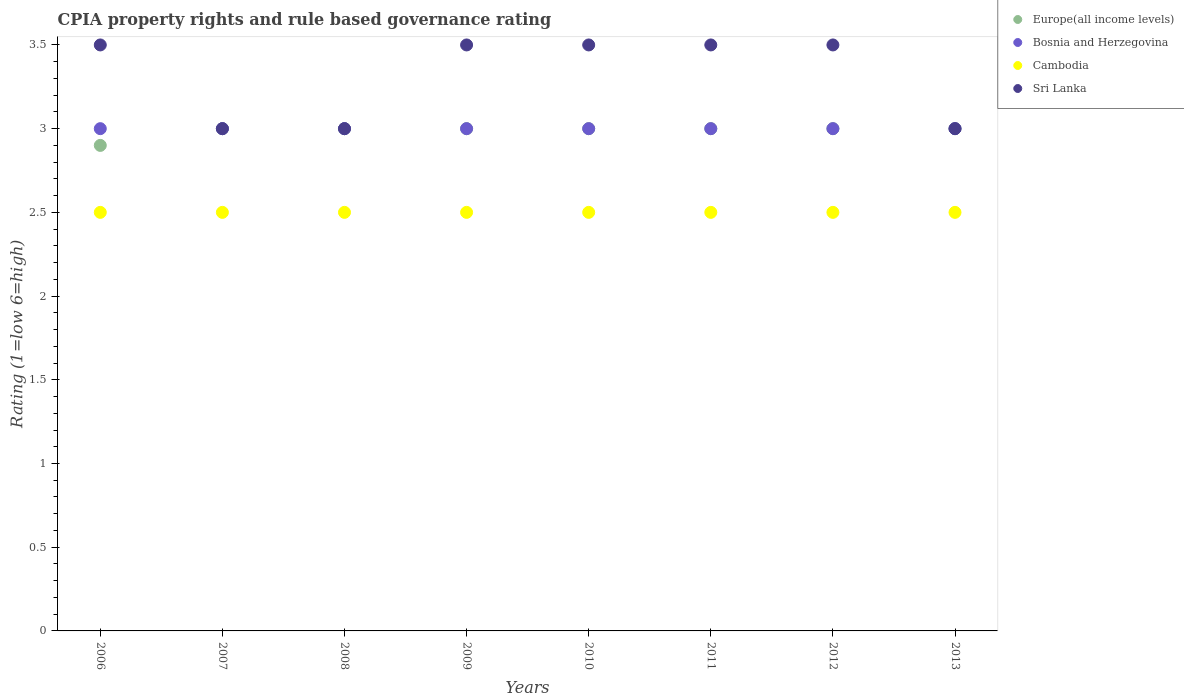How many different coloured dotlines are there?
Offer a terse response. 4. What is the CPIA rating in Cambodia in 2013?
Provide a succinct answer. 2.5. In which year was the CPIA rating in Bosnia and Herzegovina maximum?
Keep it short and to the point. 2006. In which year was the CPIA rating in Sri Lanka minimum?
Keep it short and to the point. 2007. What is the total CPIA rating in Europe(all income levels) in the graph?
Your answer should be very brief. 23.9. What is the difference between the CPIA rating in Cambodia in 2011 and that in 2012?
Provide a short and direct response. 0. What is the difference between the CPIA rating in Cambodia in 2010 and the CPIA rating in Europe(all income levels) in 2007?
Your answer should be compact. -0.5. What is the average CPIA rating in Europe(all income levels) per year?
Your answer should be compact. 2.99. In the year 2006, what is the difference between the CPIA rating in Europe(all income levels) and CPIA rating in Sri Lanka?
Your response must be concise. -0.6. In how many years, is the CPIA rating in Europe(all income levels) greater than 2.2?
Your response must be concise. 8. What is the ratio of the CPIA rating in Sri Lanka in 2007 to that in 2012?
Make the answer very short. 0.86. Is the CPIA rating in Cambodia in 2008 less than that in 2012?
Offer a terse response. No. Is the difference between the CPIA rating in Europe(all income levels) in 2007 and 2012 greater than the difference between the CPIA rating in Sri Lanka in 2007 and 2012?
Keep it short and to the point. Yes. In how many years, is the CPIA rating in Europe(all income levels) greater than the average CPIA rating in Europe(all income levels) taken over all years?
Make the answer very short. 7. Is it the case that in every year, the sum of the CPIA rating in Cambodia and CPIA rating in Bosnia and Herzegovina  is greater than the sum of CPIA rating in Sri Lanka and CPIA rating in Europe(all income levels)?
Offer a terse response. No. Is it the case that in every year, the sum of the CPIA rating in Sri Lanka and CPIA rating in Bosnia and Herzegovina  is greater than the CPIA rating in Europe(all income levels)?
Offer a terse response. Yes. Is the CPIA rating in Europe(all income levels) strictly less than the CPIA rating in Sri Lanka over the years?
Your answer should be very brief. No. How many years are there in the graph?
Your answer should be very brief. 8. What is the difference between two consecutive major ticks on the Y-axis?
Give a very brief answer. 0.5. Are the values on the major ticks of Y-axis written in scientific E-notation?
Your answer should be very brief. No. Does the graph contain any zero values?
Offer a terse response. No. Does the graph contain grids?
Provide a succinct answer. No. What is the title of the graph?
Your response must be concise. CPIA property rights and rule based governance rating. What is the Rating (1=low 6=high) of Europe(all income levels) in 2007?
Offer a very short reply. 3. What is the Rating (1=low 6=high) of Bosnia and Herzegovina in 2007?
Make the answer very short. 3. What is the Rating (1=low 6=high) in Cambodia in 2007?
Give a very brief answer. 2.5. What is the Rating (1=low 6=high) in Europe(all income levels) in 2008?
Ensure brevity in your answer.  3. What is the Rating (1=low 6=high) in Sri Lanka in 2008?
Provide a short and direct response. 3. What is the Rating (1=low 6=high) in Europe(all income levels) in 2009?
Provide a short and direct response. 3. What is the Rating (1=low 6=high) of Bosnia and Herzegovina in 2009?
Offer a terse response. 3. What is the Rating (1=low 6=high) of Cambodia in 2009?
Your answer should be very brief. 2.5. What is the Rating (1=low 6=high) in Sri Lanka in 2009?
Offer a terse response. 3.5. What is the Rating (1=low 6=high) in Sri Lanka in 2010?
Keep it short and to the point. 3.5. What is the Rating (1=low 6=high) of Cambodia in 2011?
Your answer should be compact. 2.5. What is the Rating (1=low 6=high) in Sri Lanka in 2011?
Make the answer very short. 3.5. What is the Rating (1=low 6=high) of Europe(all income levels) in 2012?
Provide a short and direct response. 3. What is the Rating (1=low 6=high) in Sri Lanka in 2012?
Provide a succinct answer. 3.5. What is the Rating (1=low 6=high) of Bosnia and Herzegovina in 2013?
Offer a terse response. 3. What is the Rating (1=low 6=high) in Cambodia in 2013?
Offer a terse response. 2.5. What is the Rating (1=low 6=high) of Sri Lanka in 2013?
Provide a succinct answer. 3. Across all years, what is the minimum Rating (1=low 6=high) of Bosnia and Herzegovina?
Give a very brief answer. 3. Across all years, what is the minimum Rating (1=low 6=high) in Cambodia?
Your answer should be compact. 2.5. What is the total Rating (1=low 6=high) in Europe(all income levels) in the graph?
Your response must be concise. 23.9. What is the total Rating (1=low 6=high) of Bosnia and Herzegovina in the graph?
Offer a very short reply. 24. What is the total Rating (1=low 6=high) in Sri Lanka in the graph?
Provide a succinct answer. 26.5. What is the difference between the Rating (1=low 6=high) of Europe(all income levels) in 2006 and that in 2007?
Your answer should be compact. -0.1. What is the difference between the Rating (1=low 6=high) of Cambodia in 2006 and that in 2007?
Keep it short and to the point. 0. What is the difference between the Rating (1=low 6=high) in Europe(all income levels) in 2006 and that in 2008?
Make the answer very short. -0.1. What is the difference between the Rating (1=low 6=high) of Bosnia and Herzegovina in 2006 and that in 2009?
Your answer should be compact. 0. What is the difference between the Rating (1=low 6=high) in Cambodia in 2006 and that in 2009?
Offer a terse response. 0. What is the difference between the Rating (1=low 6=high) of Europe(all income levels) in 2006 and that in 2010?
Provide a succinct answer. -0.1. What is the difference between the Rating (1=low 6=high) in Bosnia and Herzegovina in 2006 and that in 2010?
Keep it short and to the point. 0. What is the difference between the Rating (1=low 6=high) in Cambodia in 2006 and that in 2010?
Provide a short and direct response. 0. What is the difference between the Rating (1=low 6=high) in Sri Lanka in 2006 and that in 2010?
Provide a short and direct response. 0. What is the difference between the Rating (1=low 6=high) of Bosnia and Herzegovina in 2006 and that in 2011?
Your answer should be very brief. 0. What is the difference between the Rating (1=low 6=high) in Sri Lanka in 2006 and that in 2011?
Provide a short and direct response. 0. What is the difference between the Rating (1=low 6=high) in Bosnia and Herzegovina in 2006 and that in 2012?
Keep it short and to the point. 0. What is the difference between the Rating (1=low 6=high) of Cambodia in 2006 and that in 2012?
Your answer should be very brief. 0. What is the difference between the Rating (1=low 6=high) of Sri Lanka in 2006 and that in 2012?
Provide a short and direct response. 0. What is the difference between the Rating (1=low 6=high) of Cambodia in 2006 and that in 2013?
Give a very brief answer. 0. What is the difference between the Rating (1=low 6=high) of Sri Lanka in 2006 and that in 2013?
Make the answer very short. 0.5. What is the difference between the Rating (1=low 6=high) of Europe(all income levels) in 2007 and that in 2008?
Provide a succinct answer. 0. What is the difference between the Rating (1=low 6=high) of Europe(all income levels) in 2007 and that in 2009?
Give a very brief answer. 0. What is the difference between the Rating (1=low 6=high) of Bosnia and Herzegovina in 2007 and that in 2009?
Your response must be concise. 0. What is the difference between the Rating (1=low 6=high) in Sri Lanka in 2007 and that in 2009?
Your answer should be very brief. -0.5. What is the difference between the Rating (1=low 6=high) of Europe(all income levels) in 2007 and that in 2010?
Your answer should be compact. 0. What is the difference between the Rating (1=low 6=high) of Bosnia and Herzegovina in 2007 and that in 2010?
Provide a succinct answer. 0. What is the difference between the Rating (1=low 6=high) in Cambodia in 2007 and that in 2010?
Give a very brief answer. 0. What is the difference between the Rating (1=low 6=high) of Europe(all income levels) in 2007 and that in 2011?
Ensure brevity in your answer.  0. What is the difference between the Rating (1=low 6=high) of Europe(all income levels) in 2007 and that in 2012?
Provide a short and direct response. 0. What is the difference between the Rating (1=low 6=high) in Bosnia and Herzegovina in 2007 and that in 2012?
Your answer should be very brief. 0. What is the difference between the Rating (1=low 6=high) of Bosnia and Herzegovina in 2007 and that in 2013?
Ensure brevity in your answer.  0. What is the difference between the Rating (1=low 6=high) of Sri Lanka in 2007 and that in 2013?
Offer a terse response. 0. What is the difference between the Rating (1=low 6=high) of Bosnia and Herzegovina in 2008 and that in 2009?
Keep it short and to the point. 0. What is the difference between the Rating (1=low 6=high) in Cambodia in 2008 and that in 2009?
Ensure brevity in your answer.  0. What is the difference between the Rating (1=low 6=high) in Cambodia in 2008 and that in 2010?
Make the answer very short. 0. What is the difference between the Rating (1=low 6=high) in Sri Lanka in 2008 and that in 2010?
Make the answer very short. -0.5. What is the difference between the Rating (1=low 6=high) of Europe(all income levels) in 2008 and that in 2011?
Keep it short and to the point. 0. What is the difference between the Rating (1=low 6=high) in Bosnia and Herzegovina in 2008 and that in 2011?
Your response must be concise. 0. What is the difference between the Rating (1=low 6=high) of Cambodia in 2008 and that in 2011?
Your response must be concise. 0. What is the difference between the Rating (1=low 6=high) in Sri Lanka in 2008 and that in 2011?
Make the answer very short. -0.5. What is the difference between the Rating (1=low 6=high) in Europe(all income levels) in 2008 and that in 2012?
Offer a terse response. 0. What is the difference between the Rating (1=low 6=high) in Bosnia and Herzegovina in 2008 and that in 2012?
Provide a succinct answer. 0. What is the difference between the Rating (1=low 6=high) in Cambodia in 2008 and that in 2012?
Provide a succinct answer. 0. What is the difference between the Rating (1=low 6=high) in Sri Lanka in 2008 and that in 2012?
Provide a succinct answer. -0.5. What is the difference between the Rating (1=low 6=high) in Cambodia in 2009 and that in 2010?
Ensure brevity in your answer.  0. What is the difference between the Rating (1=low 6=high) in Sri Lanka in 2009 and that in 2010?
Provide a short and direct response. 0. What is the difference between the Rating (1=low 6=high) of Bosnia and Herzegovina in 2009 and that in 2011?
Provide a short and direct response. 0. What is the difference between the Rating (1=low 6=high) in Cambodia in 2009 and that in 2011?
Offer a very short reply. 0. What is the difference between the Rating (1=low 6=high) in Sri Lanka in 2009 and that in 2011?
Give a very brief answer. 0. What is the difference between the Rating (1=low 6=high) of Europe(all income levels) in 2009 and that in 2012?
Keep it short and to the point. 0. What is the difference between the Rating (1=low 6=high) in Cambodia in 2009 and that in 2012?
Ensure brevity in your answer.  0. What is the difference between the Rating (1=low 6=high) of Sri Lanka in 2009 and that in 2012?
Your response must be concise. 0. What is the difference between the Rating (1=low 6=high) of Bosnia and Herzegovina in 2009 and that in 2013?
Give a very brief answer. 0. What is the difference between the Rating (1=low 6=high) of Cambodia in 2009 and that in 2013?
Provide a succinct answer. 0. What is the difference between the Rating (1=low 6=high) of Europe(all income levels) in 2010 and that in 2011?
Make the answer very short. 0. What is the difference between the Rating (1=low 6=high) in Bosnia and Herzegovina in 2010 and that in 2011?
Make the answer very short. 0. What is the difference between the Rating (1=low 6=high) of Sri Lanka in 2010 and that in 2011?
Your answer should be very brief. 0. What is the difference between the Rating (1=low 6=high) of Bosnia and Herzegovina in 2010 and that in 2012?
Offer a very short reply. 0. What is the difference between the Rating (1=low 6=high) in Cambodia in 2010 and that in 2012?
Give a very brief answer. 0. What is the difference between the Rating (1=low 6=high) in Sri Lanka in 2011 and that in 2012?
Your answer should be compact. 0. What is the difference between the Rating (1=low 6=high) of Bosnia and Herzegovina in 2011 and that in 2013?
Ensure brevity in your answer.  0. What is the difference between the Rating (1=low 6=high) in Cambodia in 2011 and that in 2013?
Your response must be concise. 0. What is the difference between the Rating (1=low 6=high) in Sri Lanka in 2012 and that in 2013?
Your response must be concise. 0.5. What is the difference between the Rating (1=low 6=high) of Europe(all income levels) in 2006 and the Rating (1=low 6=high) of Cambodia in 2007?
Keep it short and to the point. 0.4. What is the difference between the Rating (1=low 6=high) of Europe(all income levels) in 2006 and the Rating (1=low 6=high) of Sri Lanka in 2007?
Make the answer very short. -0.1. What is the difference between the Rating (1=low 6=high) of Bosnia and Herzegovina in 2006 and the Rating (1=low 6=high) of Cambodia in 2007?
Your answer should be very brief. 0.5. What is the difference between the Rating (1=low 6=high) of Bosnia and Herzegovina in 2006 and the Rating (1=low 6=high) of Sri Lanka in 2007?
Provide a succinct answer. 0. What is the difference between the Rating (1=low 6=high) in Cambodia in 2006 and the Rating (1=low 6=high) in Sri Lanka in 2007?
Your response must be concise. -0.5. What is the difference between the Rating (1=low 6=high) in Europe(all income levels) in 2006 and the Rating (1=low 6=high) in Bosnia and Herzegovina in 2008?
Your response must be concise. -0.1. What is the difference between the Rating (1=low 6=high) of Europe(all income levels) in 2006 and the Rating (1=low 6=high) of Cambodia in 2008?
Make the answer very short. 0.4. What is the difference between the Rating (1=low 6=high) of Europe(all income levels) in 2006 and the Rating (1=low 6=high) of Sri Lanka in 2009?
Your answer should be very brief. -0.6. What is the difference between the Rating (1=low 6=high) in Bosnia and Herzegovina in 2006 and the Rating (1=low 6=high) in Cambodia in 2009?
Your answer should be compact. 0.5. What is the difference between the Rating (1=low 6=high) in Bosnia and Herzegovina in 2006 and the Rating (1=low 6=high) in Sri Lanka in 2009?
Keep it short and to the point. -0.5. What is the difference between the Rating (1=low 6=high) in Europe(all income levels) in 2006 and the Rating (1=low 6=high) in Bosnia and Herzegovina in 2010?
Give a very brief answer. -0.1. What is the difference between the Rating (1=low 6=high) of Bosnia and Herzegovina in 2006 and the Rating (1=low 6=high) of Cambodia in 2010?
Make the answer very short. 0.5. What is the difference between the Rating (1=low 6=high) of Bosnia and Herzegovina in 2006 and the Rating (1=low 6=high) of Sri Lanka in 2010?
Offer a very short reply. -0.5. What is the difference between the Rating (1=low 6=high) in Europe(all income levels) in 2006 and the Rating (1=low 6=high) in Bosnia and Herzegovina in 2011?
Your answer should be compact. -0.1. What is the difference between the Rating (1=low 6=high) in Bosnia and Herzegovina in 2006 and the Rating (1=low 6=high) in Sri Lanka in 2011?
Keep it short and to the point. -0.5. What is the difference between the Rating (1=low 6=high) of Cambodia in 2006 and the Rating (1=low 6=high) of Sri Lanka in 2011?
Provide a succinct answer. -1. What is the difference between the Rating (1=low 6=high) of Europe(all income levels) in 2006 and the Rating (1=low 6=high) of Sri Lanka in 2012?
Offer a terse response. -0.6. What is the difference between the Rating (1=low 6=high) of Bosnia and Herzegovina in 2006 and the Rating (1=low 6=high) of Sri Lanka in 2012?
Give a very brief answer. -0.5. What is the difference between the Rating (1=low 6=high) of Europe(all income levels) in 2006 and the Rating (1=low 6=high) of Cambodia in 2013?
Your answer should be compact. 0.4. What is the difference between the Rating (1=low 6=high) of Europe(all income levels) in 2006 and the Rating (1=low 6=high) of Sri Lanka in 2013?
Offer a terse response. -0.1. What is the difference between the Rating (1=low 6=high) in Bosnia and Herzegovina in 2006 and the Rating (1=low 6=high) in Sri Lanka in 2013?
Offer a very short reply. 0. What is the difference between the Rating (1=low 6=high) of Cambodia in 2006 and the Rating (1=low 6=high) of Sri Lanka in 2013?
Ensure brevity in your answer.  -0.5. What is the difference between the Rating (1=low 6=high) of Europe(all income levels) in 2007 and the Rating (1=low 6=high) of Bosnia and Herzegovina in 2008?
Offer a terse response. 0. What is the difference between the Rating (1=low 6=high) of Europe(all income levels) in 2007 and the Rating (1=low 6=high) of Cambodia in 2008?
Provide a short and direct response. 0.5. What is the difference between the Rating (1=low 6=high) in Bosnia and Herzegovina in 2007 and the Rating (1=low 6=high) in Cambodia in 2008?
Give a very brief answer. 0.5. What is the difference between the Rating (1=low 6=high) in Europe(all income levels) in 2007 and the Rating (1=low 6=high) in Bosnia and Herzegovina in 2009?
Keep it short and to the point. 0. What is the difference between the Rating (1=low 6=high) in Europe(all income levels) in 2007 and the Rating (1=low 6=high) in Sri Lanka in 2009?
Your response must be concise. -0.5. What is the difference between the Rating (1=low 6=high) of Bosnia and Herzegovina in 2007 and the Rating (1=low 6=high) of Cambodia in 2009?
Your answer should be very brief. 0.5. What is the difference between the Rating (1=low 6=high) of Bosnia and Herzegovina in 2007 and the Rating (1=low 6=high) of Sri Lanka in 2009?
Your answer should be very brief. -0.5. What is the difference between the Rating (1=low 6=high) in Cambodia in 2007 and the Rating (1=low 6=high) in Sri Lanka in 2009?
Give a very brief answer. -1. What is the difference between the Rating (1=low 6=high) of Bosnia and Herzegovina in 2007 and the Rating (1=low 6=high) of Cambodia in 2010?
Provide a succinct answer. 0.5. What is the difference between the Rating (1=low 6=high) in Europe(all income levels) in 2007 and the Rating (1=low 6=high) in Sri Lanka in 2011?
Provide a succinct answer. -0.5. What is the difference between the Rating (1=low 6=high) of Bosnia and Herzegovina in 2007 and the Rating (1=low 6=high) of Cambodia in 2011?
Keep it short and to the point. 0.5. What is the difference between the Rating (1=low 6=high) of Bosnia and Herzegovina in 2007 and the Rating (1=low 6=high) of Sri Lanka in 2011?
Your response must be concise. -0.5. What is the difference between the Rating (1=low 6=high) of Europe(all income levels) in 2007 and the Rating (1=low 6=high) of Sri Lanka in 2012?
Offer a terse response. -0.5. What is the difference between the Rating (1=low 6=high) in Bosnia and Herzegovina in 2007 and the Rating (1=low 6=high) in Cambodia in 2012?
Offer a terse response. 0.5. What is the difference between the Rating (1=low 6=high) of Europe(all income levels) in 2007 and the Rating (1=low 6=high) of Cambodia in 2013?
Ensure brevity in your answer.  0.5. What is the difference between the Rating (1=low 6=high) in Europe(all income levels) in 2007 and the Rating (1=low 6=high) in Sri Lanka in 2013?
Your response must be concise. 0. What is the difference between the Rating (1=low 6=high) in Bosnia and Herzegovina in 2007 and the Rating (1=low 6=high) in Cambodia in 2013?
Give a very brief answer. 0.5. What is the difference between the Rating (1=low 6=high) in Europe(all income levels) in 2008 and the Rating (1=low 6=high) in Bosnia and Herzegovina in 2009?
Offer a very short reply. 0. What is the difference between the Rating (1=low 6=high) in Europe(all income levels) in 2008 and the Rating (1=low 6=high) in Cambodia in 2009?
Your answer should be compact. 0.5. What is the difference between the Rating (1=low 6=high) of Bosnia and Herzegovina in 2008 and the Rating (1=low 6=high) of Sri Lanka in 2009?
Your response must be concise. -0.5. What is the difference between the Rating (1=low 6=high) of Europe(all income levels) in 2008 and the Rating (1=low 6=high) of Bosnia and Herzegovina in 2010?
Offer a very short reply. 0. What is the difference between the Rating (1=low 6=high) in Europe(all income levels) in 2008 and the Rating (1=low 6=high) in Sri Lanka in 2010?
Provide a succinct answer. -0.5. What is the difference between the Rating (1=low 6=high) of Bosnia and Herzegovina in 2008 and the Rating (1=low 6=high) of Cambodia in 2010?
Your answer should be very brief. 0.5. What is the difference between the Rating (1=low 6=high) of Bosnia and Herzegovina in 2008 and the Rating (1=low 6=high) of Sri Lanka in 2010?
Provide a succinct answer. -0.5. What is the difference between the Rating (1=low 6=high) of Cambodia in 2008 and the Rating (1=low 6=high) of Sri Lanka in 2010?
Your answer should be compact. -1. What is the difference between the Rating (1=low 6=high) of Europe(all income levels) in 2008 and the Rating (1=low 6=high) of Bosnia and Herzegovina in 2011?
Keep it short and to the point. 0. What is the difference between the Rating (1=low 6=high) in Europe(all income levels) in 2008 and the Rating (1=low 6=high) in Cambodia in 2011?
Make the answer very short. 0.5. What is the difference between the Rating (1=low 6=high) in Bosnia and Herzegovina in 2008 and the Rating (1=low 6=high) in Cambodia in 2011?
Provide a succinct answer. 0.5. What is the difference between the Rating (1=low 6=high) of Bosnia and Herzegovina in 2008 and the Rating (1=low 6=high) of Sri Lanka in 2011?
Give a very brief answer. -0.5. What is the difference between the Rating (1=low 6=high) of Cambodia in 2008 and the Rating (1=low 6=high) of Sri Lanka in 2011?
Your answer should be compact. -1. What is the difference between the Rating (1=low 6=high) in Europe(all income levels) in 2008 and the Rating (1=low 6=high) in Cambodia in 2012?
Ensure brevity in your answer.  0.5. What is the difference between the Rating (1=low 6=high) of Bosnia and Herzegovina in 2008 and the Rating (1=low 6=high) of Sri Lanka in 2012?
Offer a terse response. -0.5. What is the difference between the Rating (1=low 6=high) of Europe(all income levels) in 2008 and the Rating (1=low 6=high) of Bosnia and Herzegovina in 2013?
Provide a short and direct response. 0. What is the difference between the Rating (1=low 6=high) in Bosnia and Herzegovina in 2008 and the Rating (1=low 6=high) in Sri Lanka in 2013?
Provide a succinct answer. 0. What is the difference between the Rating (1=low 6=high) in Europe(all income levels) in 2009 and the Rating (1=low 6=high) in Cambodia in 2010?
Make the answer very short. 0.5. What is the difference between the Rating (1=low 6=high) in Europe(all income levels) in 2009 and the Rating (1=low 6=high) in Sri Lanka in 2010?
Offer a terse response. -0.5. What is the difference between the Rating (1=low 6=high) of Bosnia and Herzegovina in 2009 and the Rating (1=low 6=high) of Sri Lanka in 2010?
Make the answer very short. -0.5. What is the difference between the Rating (1=low 6=high) in Cambodia in 2009 and the Rating (1=low 6=high) in Sri Lanka in 2010?
Give a very brief answer. -1. What is the difference between the Rating (1=low 6=high) of Bosnia and Herzegovina in 2009 and the Rating (1=low 6=high) of Cambodia in 2011?
Provide a short and direct response. 0.5. What is the difference between the Rating (1=low 6=high) of Bosnia and Herzegovina in 2009 and the Rating (1=low 6=high) of Sri Lanka in 2011?
Your answer should be compact. -0.5. What is the difference between the Rating (1=low 6=high) of Europe(all income levels) in 2009 and the Rating (1=low 6=high) of Cambodia in 2012?
Give a very brief answer. 0.5. What is the difference between the Rating (1=low 6=high) in Europe(all income levels) in 2009 and the Rating (1=low 6=high) in Sri Lanka in 2012?
Keep it short and to the point. -0.5. What is the difference between the Rating (1=low 6=high) of Bosnia and Herzegovina in 2009 and the Rating (1=low 6=high) of Cambodia in 2012?
Offer a very short reply. 0.5. What is the difference between the Rating (1=low 6=high) in Bosnia and Herzegovina in 2009 and the Rating (1=low 6=high) in Sri Lanka in 2012?
Your response must be concise. -0.5. What is the difference between the Rating (1=low 6=high) in Europe(all income levels) in 2009 and the Rating (1=low 6=high) in Bosnia and Herzegovina in 2013?
Your answer should be compact. 0. What is the difference between the Rating (1=low 6=high) in Cambodia in 2009 and the Rating (1=low 6=high) in Sri Lanka in 2013?
Provide a succinct answer. -0.5. What is the difference between the Rating (1=low 6=high) of Europe(all income levels) in 2010 and the Rating (1=low 6=high) of Cambodia in 2011?
Ensure brevity in your answer.  0.5. What is the difference between the Rating (1=low 6=high) in Europe(all income levels) in 2010 and the Rating (1=low 6=high) in Sri Lanka in 2011?
Offer a very short reply. -0.5. What is the difference between the Rating (1=low 6=high) in Cambodia in 2010 and the Rating (1=low 6=high) in Sri Lanka in 2011?
Your answer should be compact. -1. What is the difference between the Rating (1=low 6=high) in Europe(all income levels) in 2010 and the Rating (1=low 6=high) in Bosnia and Herzegovina in 2012?
Your response must be concise. 0. What is the difference between the Rating (1=low 6=high) of Europe(all income levels) in 2010 and the Rating (1=low 6=high) of Cambodia in 2012?
Offer a very short reply. 0.5. What is the difference between the Rating (1=low 6=high) in Bosnia and Herzegovina in 2010 and the Rating (1=low 6=high) in Sri Lanka in 2012?
Your response must be concise. -0.5. What is the difference between the Rating (1=low 6=high) in Europe(all income levels) in 2010 and the Rating (1=low 6=high) in Bosnia and Herzegovina in 2013?
Keep it short and to the point. 0. What is the difference between the Rating (1=low 6=high) of Europe(all income levels) in 2010 and the Rating (1=low 6=high) of Cambodia in 2013?
Provide a succinct answer. 0.5. What is the difference between the Rating (1=low 6=high) in Europe(all income levels) in 2010 and the Rating (1=low 6=high) in Sri Lanka in 2013?
Your response must be concise. 0. What is the difference between the Rating (1=low 6=high) of Europe(all income levels) in 2011 and the Rating (1=low 6=high) of Bosnia and Herzegovina in 2012?
Provide a succinct answer. 0. What is the difference between the Rating (1=low 6=high) of Europe(all income levels) in 2011 and the Rating (1=low 6=high) of Cambodia in 2013?
Offer a very short reply. 0.5. What is the difference between the Rating (1=low 6=high) of Europe(all income levels) in 2011 and the Rating (1=low 6=high) of Sri Lanka in 2013?
Your response must be concise. 0. What is the difference between the Rating (1=low 6=high) of Cambodia in 2011 and the Rating (1=low 6=high) of Sri Lanka in 2013?
Offer a very short reply. -0.5. What is the difference between the Rating (1=low 6=high) in Europe(all income levels) in 2012 and the Rating (1=low 6=high) in Bosnia and Herzegovina in 2013?
Give a very brief answer. 0. What is the difference between the Rating (1=low 6=high) in Europe(all income levels) in 2012 and the Rating (1=low 6=high) in Cambodia in 2013?
Your response must be concise. 0.5. What is the difference between the Rating (1=low 6=high) of Europe(all income levels) in 2012 and the Rating (1=low 6=high) of Sri Lanka in 2013?
Make the answer very short. 0. What is the difference between the Rating (1=low 6=high) of Bosnia and Herzegovina in 2012 and the Rating (1=low 6=high) of Cambodia in 2013?
Provide a succinct answer. 0.5. What is the difference between the Rating (1=low 6=high) of Cambodia in 2012 and the Rating (1=low 6=high) of Sri Lanka in 2013?
Your response must be concise. -0.5. What is the average Rating (1=low 6=high) of Europe(all income levels) per year?
Make the answer very short. 2.99. What is the average Rating (1=low 6=high) of Bosnia and Herzegovina per year?
Offer a terse response. 3. What is the average Rating (1=low 6=high) in Sri Lanka per year?
Provide a succinct answer. 3.31. In the year 2006, what is the difference between the Rating (1=low 6=high) of Europe(all income levels) and Rating (1=low 6=high) of Bosnia and Herzegovina?
Keep it short and to the point. -0.1. In the year 2006, what is the difference between the Rating (1=low 6=high) of Bosnia and Herzegovina and Rating (1=low 6=high) of Cambodia?
Provide a short and direct response. 0.5. In the year 2006, what is the difference between the Rating (1=low 6=high) of Cambodia and Rating (1=low 6=high) of Sri Lanka?
Offer a very short reply. -1. In the year 2007, what is the difference between the Rating (1=low 6=high) of Europe(all income levels) and Rating (1=low 6=high) of Sri Lanka?
Make the answer very short. 0. In the year 2007, what is the difference between the Rating (1=low 6=high) in Bosnia and Herzegovina and Rating (1=low 6=high) in Cambodia?
Make the answer very short. 0.5. In the year 2007, what is the difference between the Rating (1=low 6=high) of Bosnia and Herzegovina and Rating (1=low 6=high) of Sri Lanka?
Provide a short and direct response. 0. In the year 2008, what is the difference between the Rating (1=low 6=high) of Europe(all income levels) and Rating (1=low 6=high) of Bosnia and Herzegovina?
Your answer should be very brief. 0. In the year 2008, what is the difference between the Rating (1=low 6=high) in Europe(all income levels) and Rating (1=low 6=high) in Sri Lanka?
Provide a short and direct response. 0. In the year 2008, what is the difference between the Rating (1=low 6=high) in Bosnia and Herzegovina and Rating (1=low 6=high) in Cambodia?
Give a very brief answer. 0.5. In the year 2008, what is the difference between the Rating (1=low 6=high) of Bosnia and Herzegovina and Rating (1=low 6=high) of Sri Lanka?
Make the answer very short. 0. In the year 2009, what is the difference between the Rating (1=low 6=high) in Europe(all income levels) and Rating (1=low 6=high) in Sri Lanka?
Make the answer very short. -0.5. In the year 2009, what is the difference between the Rating (1=low 6=high) of Bosnia and Herzegovina and Rating (1=low 6=high) of Cambodia?
Offer a terse response. 0.5. In the year 2009, what is the difference between the Rating (1=low 6=high) in Cambodia and Rating (1=low 6=high) in Sri Lanka?
Give a very brief answer. -1. In the year 2010, what is the difference between the Rating (1=low 6=high) in Europe(all income levels) and Rating (1=low 6=high) in Bosnia and Herzegovina?
Your response must be concise. 0. In the year 2010, what is the difference between the Rating (1=low 6=high) in Bosnia and Herzegovina and Rating (1=low 6=high) in Cambodia?
Offer a very short reply. 0.5. In the year 2010, what is the difference between the Rating (1=low 6=high) of Cambodia and Rating (1=low 6=high) of Sri Lanka?
Make the answer very short. -1. In the year 2011, what is the difference between the Rating (1=low 6=high) of Europe(all income levels) and Rating (1=low 6=high) of Bosnia and Herzegovina?
Your answer should be compact. 0. In the year 2011, what is the difference between the Rating (1=low 6=high) in Europe(all income levels) and Rating (1=low 6=high) in Cambodia?
Offer a terse response. 0.5. In the year 2011, what is the difference between the Rating (1=low 6=high) in Europe(all income levels) and Rating (1=low 6=high) in Sri Lanka?
Ensure brevity in your answer.  -0.5. In the year 2011, what is the difference between the Rating (1=low 6=high) in Bosnia and Herzegovina and Rating (1=low 6=high) in Cambodia?
Your answer should be compact. 0.5. In the year 2011, what is the difference between the Rating (1=low 6=high) of Bosnia and Herzegovina and Rating (1=low 6=high) of Sri Lanka?
Make the answer very short. -0.5. In the year 2012, what is the difference between the Rating (1=low 6=high) of Europe(all income levels) and Rating (1=low 6=high) of Bosnia and Herzegovina?
Ensure brevity in your answer.  0. In the year 2012, what is the difference between the Rating (1=low 6=high) of Europe(all income levels) and Rating (1=low 6=high) of Cambodia?
Ensure brevity in your answer.  0.5. In the year 2012, what is the difference between the Rating (1=low 6=high) in Bosnia and Herzegovina and Rating (1=low 6=high) in Cambodia?
Give a very brief answer. 0.5. In the year 2012, what is the difference between the Rating (1=low 6=high) of Bosnia and Herzegovina and Rating (1=low 6=high) of Sri Lanka?
Your answer should be compact. -0.5. In the year 2013, what is the difference between the Rating (1=low 6=high) of Europe(all income levels) and Rating (1=low 6=high) of Bosnia and Herzegovina?
Ensure brevity in your answer.  0. In the year 2013, what is the difference between the Rating (1=low 6=high) of Europe(all income levels) and Rating (1=low 6=high) of Sri Lanka?
Give a very brief answer. 0. In the year 2013, what is the difference between the Rating (1=low 6=high) in Bosnia and Herzegovina and Rating (1=low 6=high) in Cambodia?
Provide a succinct answer. 0.5. What is the ratio of the Rating (1=low 6=high) in Europe(all income levels) in 2006 to that in 2007?
Provide a short and direct response. 0.97. What is the ratio of the Rating (1=low 6=high) of Cambodia in 2006 to that in 2007?
Provide a short and direct response. 1. What is the ratio of the Rating (1=low 6=high) of Europe(all income levels) in 2006 to that in 2008?
Offer a terse response. 0.97. What is the ratio of the Rating (1=low 6=high) of Bosnia and Herzegovina in 2006 to that in 2008?
Provide a short and direct response. 1. What is the ratio of the Rating (1=low 6=high) in Cambodia in 2006 to that in 2008?
Give a very brief answer. 1. What is the ratio of the Rating (1=low 6=high) in Sri Lanka in 2006 to that in 2008?
Ensure brevity in your answer.  1.17. What is the ratio of the Rating (1=low 6=high) of Europe(all income levels) in 2006 to that in 2009?
Provide a succinct answer. 0.97. What is the ratio of the Rating (1=low 6=high) of Cambodia in 2006 to that in 2009?
Your answer should be very brief. 1. What is the ratio of the Rating (1=low 6=high) in Europe(all income levels) in 2006 to that in 2010?
Offer a very short reply. 0.97. What is the ratio of the Rating (1=low 6=high) of Cambodia in 2006 to that in 2010?
Provide a succinct answer. 1. What is the ratio of the Rating (1=low 6=high) in Sri Lanka in 2006 to that in 2010?
Offer a terse response. 1. What is the ratio of the Rating (1=low 6=high) of Europe(all income levels) in 2006 to that in 2011?
Provide a short and direct response. 0.97. What is the ratio of the Rating (1=low 6=high) of Bosnia and Herzegovina in 2006 to that in 2011?
Your answer should be very brief. 1. What is the ratio of the Rating (1=low 6=high) in Cambodia in 2006 to that in 2011?
Your answer should be compact. 1. What is the ratio of the Rating (1=low 6=high) of Europe(all income levels) in 2006 to that in 2012?
Provide a succinct answer. 0.97. What is the ratio of the Rating (1=low 6=high) of Bosnia and Herzegovina in 2006 to that in 2012?
Your response must be concise. 1. What is the ratio of the Rating (1=low 6=high) in Europe(all income levels) in 2006 to that in 2013?
Your answer should be very brief. 0.97. What is the ratio of the Rating (1=low 6=high) of Bosnia and Herzegovina in 2006 to that in 2013?
Make the answer very short. 1. What is the ratio of the Rating (1=low 6=high) in Cambodia in 2006 to that in 2013?
Make the answer very short. 1. What is the ratio of the Rating (1=low 6=high) in Europe(all income levels) in 2007 to that in 2008?
Provide a short and direct response. 1. What is the ratio of the Rating (1=low 6=high) of Bosnia and Herzegovina in 2007 to that in 2009?
Your response must be concise. 1. What is the ratio of the Rating (1=low 6=high) of Cambodia in 2007 to that in 2009?
Your answer should be very brief. 1. What is the ratio of the Rating (1=low 6=high) of Sri Lanka in 2007 to that in 2009?
Your answer should be very brief. 0.86. What is the ratio of the Rating (1=low 6=high) of Europe(all income levels) in 2007 to that in 2011?
Give a very brief answer. 1. What is the ratio of the Rating (1=low 6=high) in Cambodia in 2007 to that in 2011?
Ensure brevity in your answer.  1. What is the ratio of the Rating (1=low 6=high) of Europe(all income levels) in 2007 to that in 2013?
Make the answer very short. 1. What is the ratio of the Rating (1=low 6=high) of Bosnia and Herzegovina in 2007 to that in 2013?
Your response must be concise. 1. What is the ratio of the Rating (1=low 6=high) in Sri Lanka in 2007 to that in 2013?
Offer a very short reply. 1. What is the ratio of the Rating (1=low 6=high) in Cambodia in 2008 to that in 2009?
Make the answer very short. 1. What is the ratio of the Rating (1=low 6=high) in Sri Lanka in 2008 to that in 2009?
Provide a short and direct response. 0.86. What is the ratio of the Rating (1=low 6=high) of Europe(all income levels) in 2008 to that in 2010?
Your answer should be very brief. 1. What is the ratio of the Rating (1=low 6=high) in Bosnia and Herzegovina in 2008 to that in 2010?
Your response must be concise. 1. What is the ratio of the Rating (1=low 6=high) of Cambodia in 2008 to that in 2010?
Give a very brief answer. 1. What is the ratio of the Rating (1=low 6=high) in Sri Lanka in 2008 to that in 2010?
Keep it short and to the point. 0.86. What is the ratio of the Rating (1=low 6=high) in Sri Lanka in 2008 to that in 2011?
Your response must be concise. 0.86. What is the ratio of the Rating (1=low 6=high) in Sri Lanka in 2008 to that in 2012?
Offer a terse response. 0.86. What is the ratio of the Rating (1=low 6=high) in Cambodia in 2008 to that in 2013?
Offer a very short reply. 1. What is the ratio of the Rating (1=low 6=high) in Cambodia in 2009 to that in 2010?
Keep it short and to the point. 1. What is the ratio of the Rating (1=low 6=high) in Sri Lanka in 2009 to that in 2010?
Provide a succinct answer. 1. What is the ratio of the Rating (1=low 6=high) in Europe(all income levels) in 2009 to that in 2011?
Keep it short and to the point. 1. What is the ratio of the Rating (1=low 6=high) in Bosnia and Herzegovina in 2009 to that in 2011?
Offer a terse response. 1. What is the ratio of the Rating (1=low 6=high) in Cambodia in 2009 to that in 2011?
Ensure brevity in your answer.  1. What is the ratio of the Rating (1=low 6=high) in Europe(all income levels) in 2009 to that in 2012?
Your answer should be compact. 1. What is the ratio of the Rating (1=low 6=high) in Sri Lanka in 2009 to that in 2012?
Your answer should be very brief. 1. What is the ratio of the Rating (1=low 6=high) of Bosnia and Herzegovina in 2009 to that in 2013?
Offer a very short reply. 1. What is the ratio of the Rating (1=low 6=high) in Sri Lanka in 2009 to that in 2013?
Give a very brief answer. 1.17. What is the ratio of the Rating (1=low 6=high) of Cambodia in 2010 to that in 2011?
Offer a terse response. 1. What is the ratio of the Rating (1=low 6=high) in Sri Lanka in 2010 to that in 2011?
Your answer should be compact. 1. What is the ratio of the Rating (1=low 6=high) of Europe(all income levels) in 2010 to that in 2012?
Provide a short and direct response. 1. What is the ratio of the Rating (1=low 6=high) in Bosnia and Herzegovina in 2010 to that in 2012?
Your response must be concise. 1. What is the ratio of the Rating (1=low 6=high) in Sri Lanka in 2010 to that in 2012?
Offer a very short reply. 1. What is the ratio of the Rating (1=low 6=high) of Europe(all income levels) in 2010 to that in 2013?
Keep it short and to the point. 1. What is the ratio of the Rating (1=low 6=high) of Cambodia in 2010 to that in 2013?
Make the answer very short. 1. What is the ratio of the Rating (1=low 6=high) of Europe(all income levels) in 2011 to that in 2012?
Provide a short and direct response. 1. What is the ratio of the Rating (1=low 6=high) of Bosnia and Herzegovina in 2011 to that in 2012?
Your answer should be compact. 1. What is the ratio of the Rating (1=low 6=high) of Europe(all income levels) in 2012 to that in 2013?
Offer a very short reply. 1. What is the ratio of the Rating (1=low 6=high) of Cambodia in 2012 to that in 2013?
Offer a very short reply. 1. What is the ratio of the Rating (1=low 6=high) in Sri Lanka in 2012 to that in 2013?
Your answer should be very brief. 1.17. What is the difference between the highest and the second highest Rating (1=low 6=high) of Europe(all income levels)?
Provide a short and direct response. 0. What is the difference between the highest and the second highest Rating (1=low 6=high) in Bosnia and Herzegovina?
Your answer should be compact. 0. What is the difference between the highest and the second highest Rating (1=low 6=high) of Sri Lanka?
Keep it short and to the point. 0. What is the difference between the highest and the lowest Rating (1=low 6=high) of Europe(all income levels)?
Provide a short and direct response. 0.1. What is the difference between the highest and the lowest Rating (1=low 6=high) of Bosnia and Herzegovina?
Provide a succinct answer. 0. What is the difference between the highest and the lowest Rating (1=low 6=high) of Cambodia?
Provide a succinct answer. 0. 